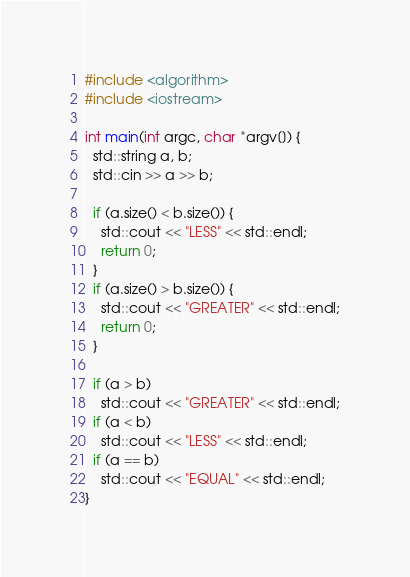<code> <loc_0><loc_0><loc_500><loc_500><_C++_>#include <algorithm>
#include <iostream>

int main(int argc, char *argv[]) {
  std::string a, b;
  std::cin >> a >> b;

  if (a.size() < b.size()) {
    std::cout << "LESS" << std::endl;
    return 0;
  } 
  if (a.size() > b.size()) {
    std::cout << "GREATER" << std::endl;
    return 0;
  } 

  if (a > b)
    std::cout << "GREATER" << std::endl;
  if (a < b)
    std::cout << "LESS" << std::endl;
  if (a == b)
    std::cout << "EQUAL" << std::endl;
}
</code> 